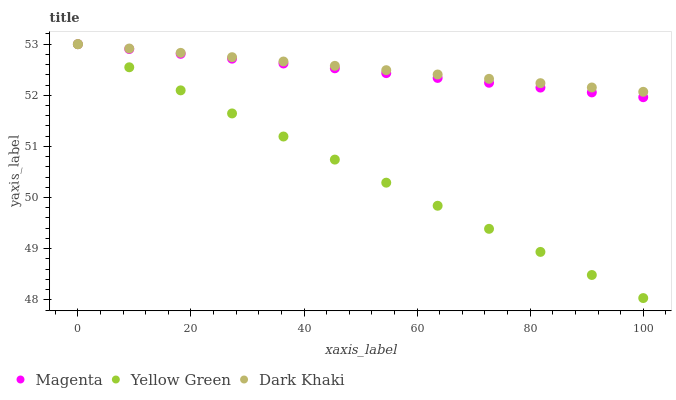Does Yellow Green have the minimum area under the curve?
Answer yes or no. Yes. Does Dark Khaki have the maximum area under the curve?
Answer yes or no. Yes. Does Magenta have the minimum area under the curve?
Answer yes or no. No. Does Magenta have the maximum area under the curve?
Answer yes or no. No. Is Yellow Green the smoothest?
Answer yes or no. Yes. Is Dark Khaki the roughest?
Answer yes or no. Yes. Is Magenta the smoothest?
Answer yes or no. No. Is Magenta the roughest?
Answer yes or no. No. Does Yellow Green have the lowest value?
Answer yes or no. Yes. Does Magenta have the lowest value?
Answer yes or no. No. Does Yellow Green have the highest value?
Answer yes or no. Yes. Does Magenta intersect Yellow Green?
Answer yes or no. Yes. Is Magenta less than Yellow Green?
Answer yes or no. No. Is Magenta greater than Yellow Green?
Answer yes or no. No. 